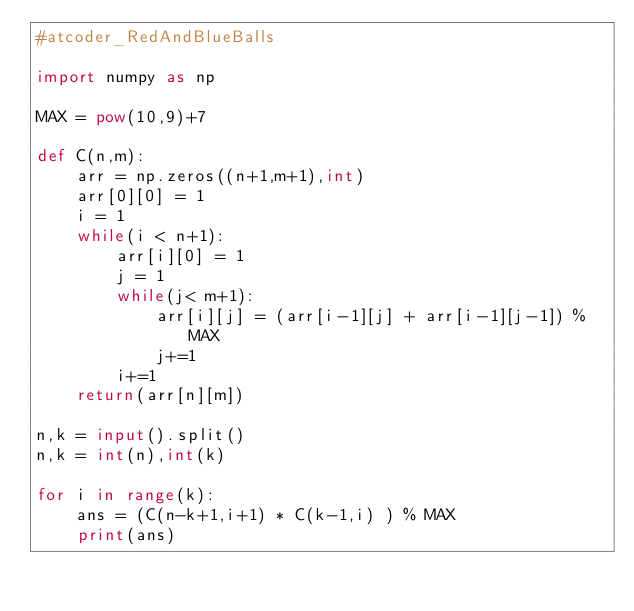<code> <loc_0><loc_0><loc_500><loc_500><_Python_>#atcoder_RedAndBlueBalls

import numpy as np 

MAX = pow(10,9)+7

def C(n,m):
    arr = np.zeros((n+1,m+1),int)
    arr[0][0] = 1 
    i = 1 
    while(i < n+1):
        arr[i][0] = 1 
        j = 1 
        while(j< m+1):
            arr[i][j] = (arr[i-1][j] + arr[i-1][j-1]) % MAX 
            j+=1 
        i+=1 
    return(arr[n][m])  

n,k = input().split()
n,k = int(n),int(k) 

for i in range(k):
    ans = (C(n-k+1,i+1) * C(k-1,i) ) % MAX 
    print(ans) 

</code> 